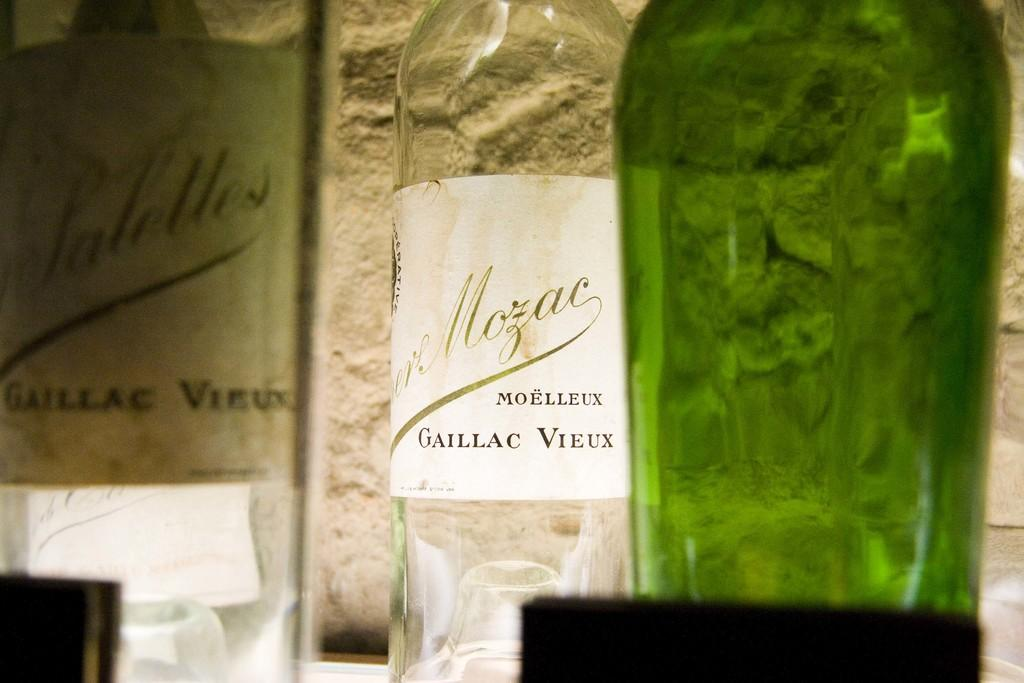<image>
Share a concise interpretation of the image provided. A bottle has the word Moelleux on the label. 